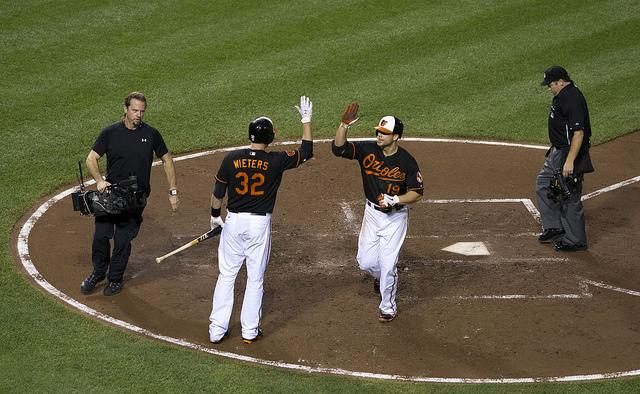What category of animal is their mascot in?

Choices:
A) snake
B) cat
C) bird
D) dog bird 